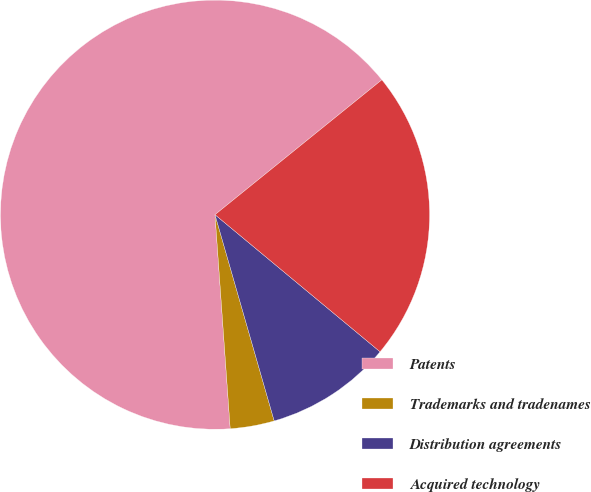Convert chart. <chart><loc_0><loc_0><loc_500><loc_500><pie_chart><fcel>Patents<fcel>Trademarks and tradenames<fcel>Distribution agreements<fcel>Acquired technology<nl><fcel>65.31%<fcel>3.32%<fcel>9.52%<fcel>21.85%<nl></chart> 